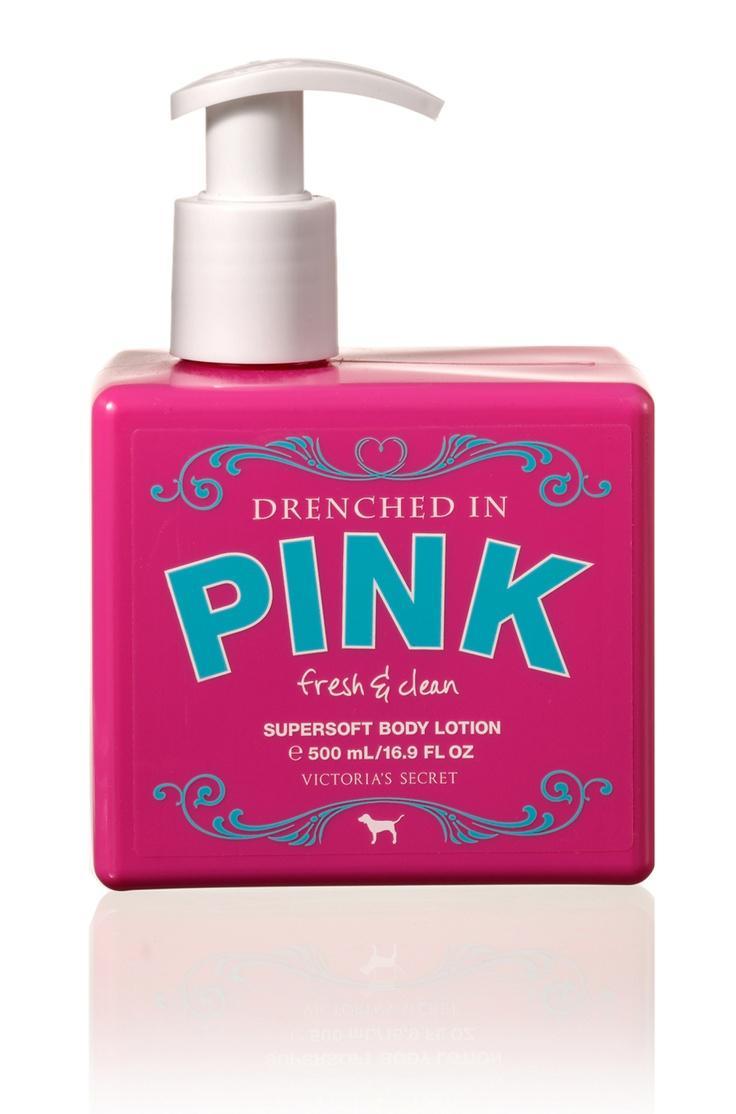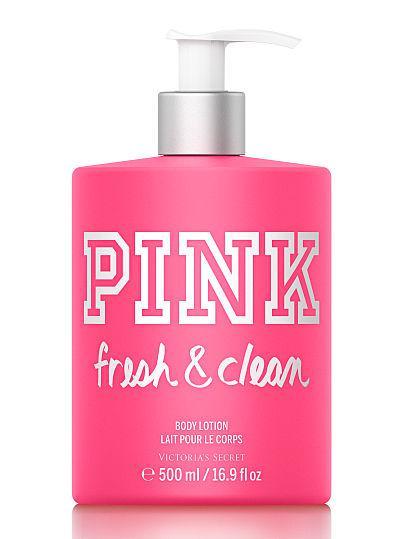The first image is the image on the left, the second image is the image on the right. Examine the images to the left and right. Is the description "At least one of the products is standing alone." accurate? Answer yes or no. Yes. The first image is the image on the left, the second image is the image on the right. For the images shown, is this caption "At least one image features a single pump-top product." true? Answer yes or no. Yes. 